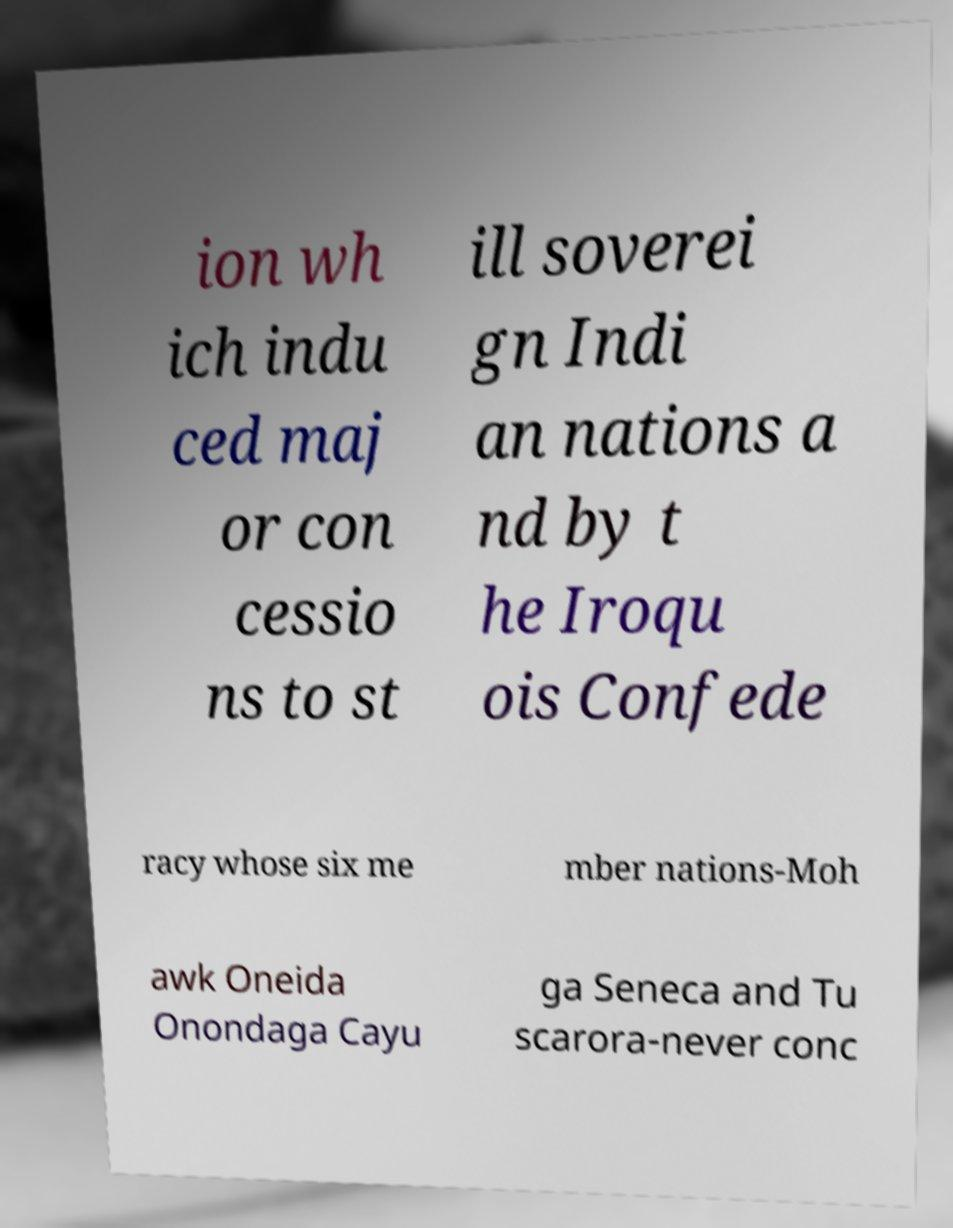There's text embedded in this image that I need extracted. Can you transcribe it verbatim? ion wh ich indu ced maj or con cessio ns to st ill soverei gn Indi an nations a nd by t he Iroqu ois Confede racy whose six me mber nations-Moh awk Oneida Onondaga Cayu ga Seneca and Tu scarora-never conc 